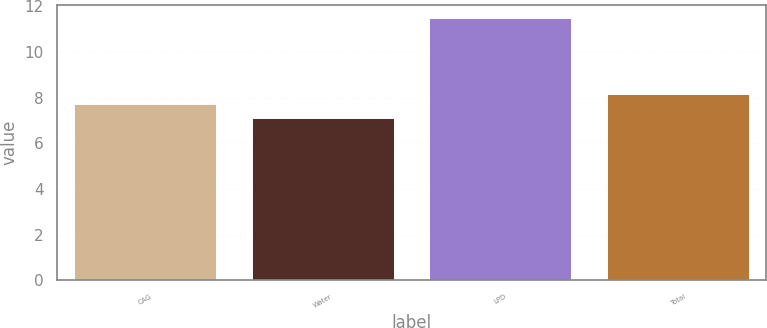Convert chart. <chart><loc_0><loc_0><loc_500><loc_500><bar_chart><fcel>CAG<fcel>Water<fcel>LPD<fcel>Total<nl><fcel>7.7<fcel>7.1<fcel>11.5<fcel>8.14<nl></chart> 